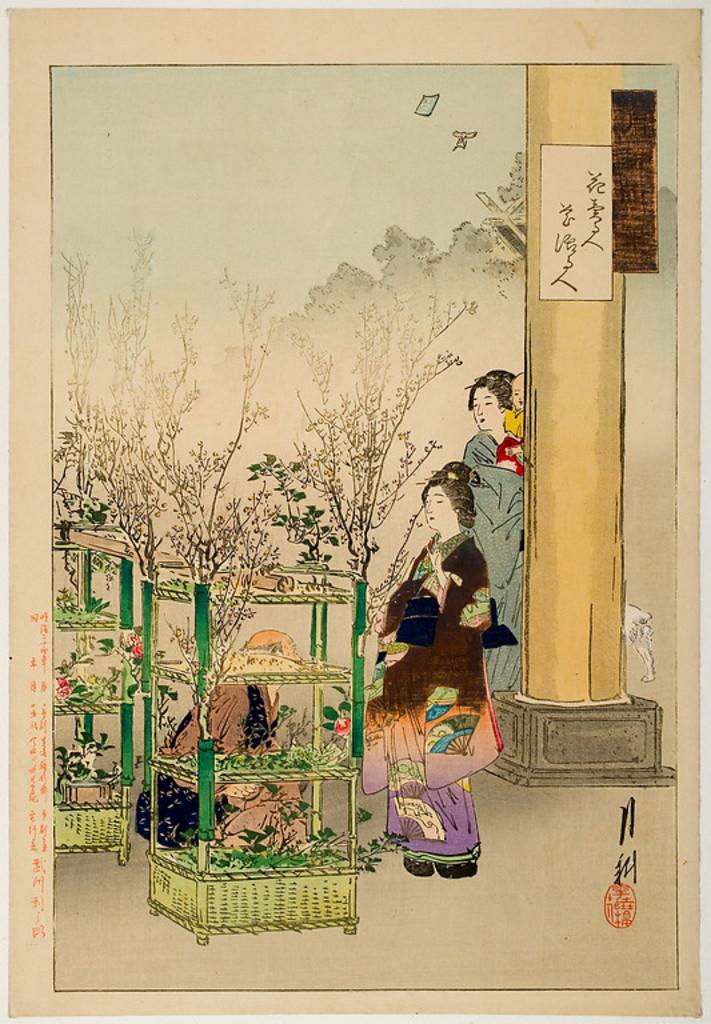What types of images are present on the paper? The paper contains pictures of people, plants, and stands. Are there any architectural elements depicted on the paper? Yes, there is a pillar depicted on the paper. How many birds can be seen flying around the pillar in the image? There are no birds present in the image; it only contains pictures of people, plants, stands, and a pillar. 